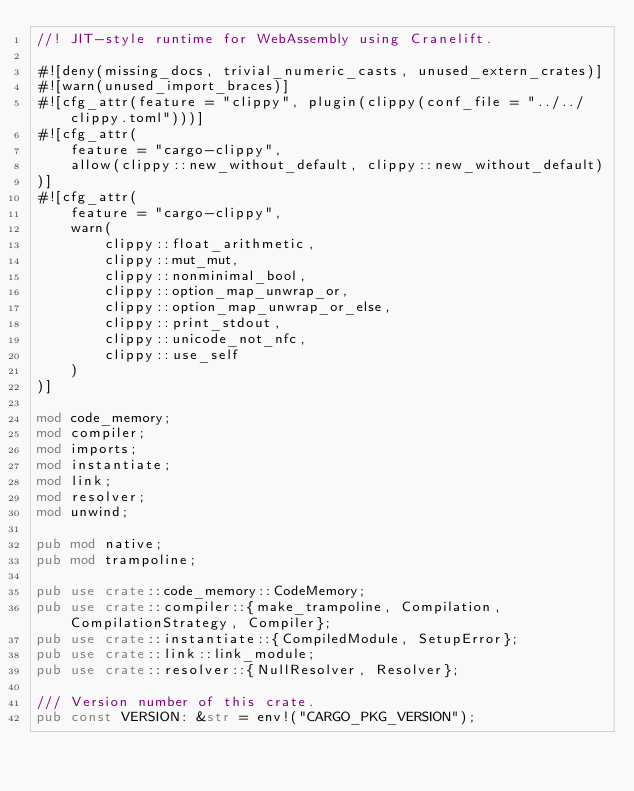Convert code to text. <code><loc_0><loc_0><loc_500><loc_500><_Rust_>//! JIT-style runtime for WebAssembly using Cranelift.

#![deny(missing_docs, trivial_numeric_casts, unused_extern_crates)]
#![warn(unused_import_braces)]
#![cfg_attr(feature = "clippy", plugin(clippy(conf_file = "../../clippy.toml")))]
#![cfg_attr(
    feature = "cargo-clippy",
    allow(clippy::new_without_default, clippy::new_without_default)
)]
#![cfg_attr(
    feature = "cargo-clippy",
    warn(
        clippy::float_arithmetic,
        clippy::mut_mut,
        clippy::nonminimal_bool,
        clippy::option_map_unwrap_or,
        clippy::option_map_unwrap_or_else,
        clippy::print_stdout,
        clippy::unicode_not_nfc,
        clippy::use_self
    )
)]

mod code_memory;
mod compiler;
mod imports;
mod instantiate;
mod link;
mod resolver;
mod unwind;

pub mod native;
pub mod trampoline;

pub use crate::code_memory::CodeMemory;
pub use crate::compiler::{make_trampoline, Compilation, CompilationStrategy, Compiler};
pub use crate::instantiate::{CompiledModule, SetupError};
pub use crate::link::link_module;
pub use crate::resolver::{NullResolver, Resolver};

/// Version number of this crate.
pub const VERSION: &str = env!("CARGO_PKG_VERSION");
</code> 